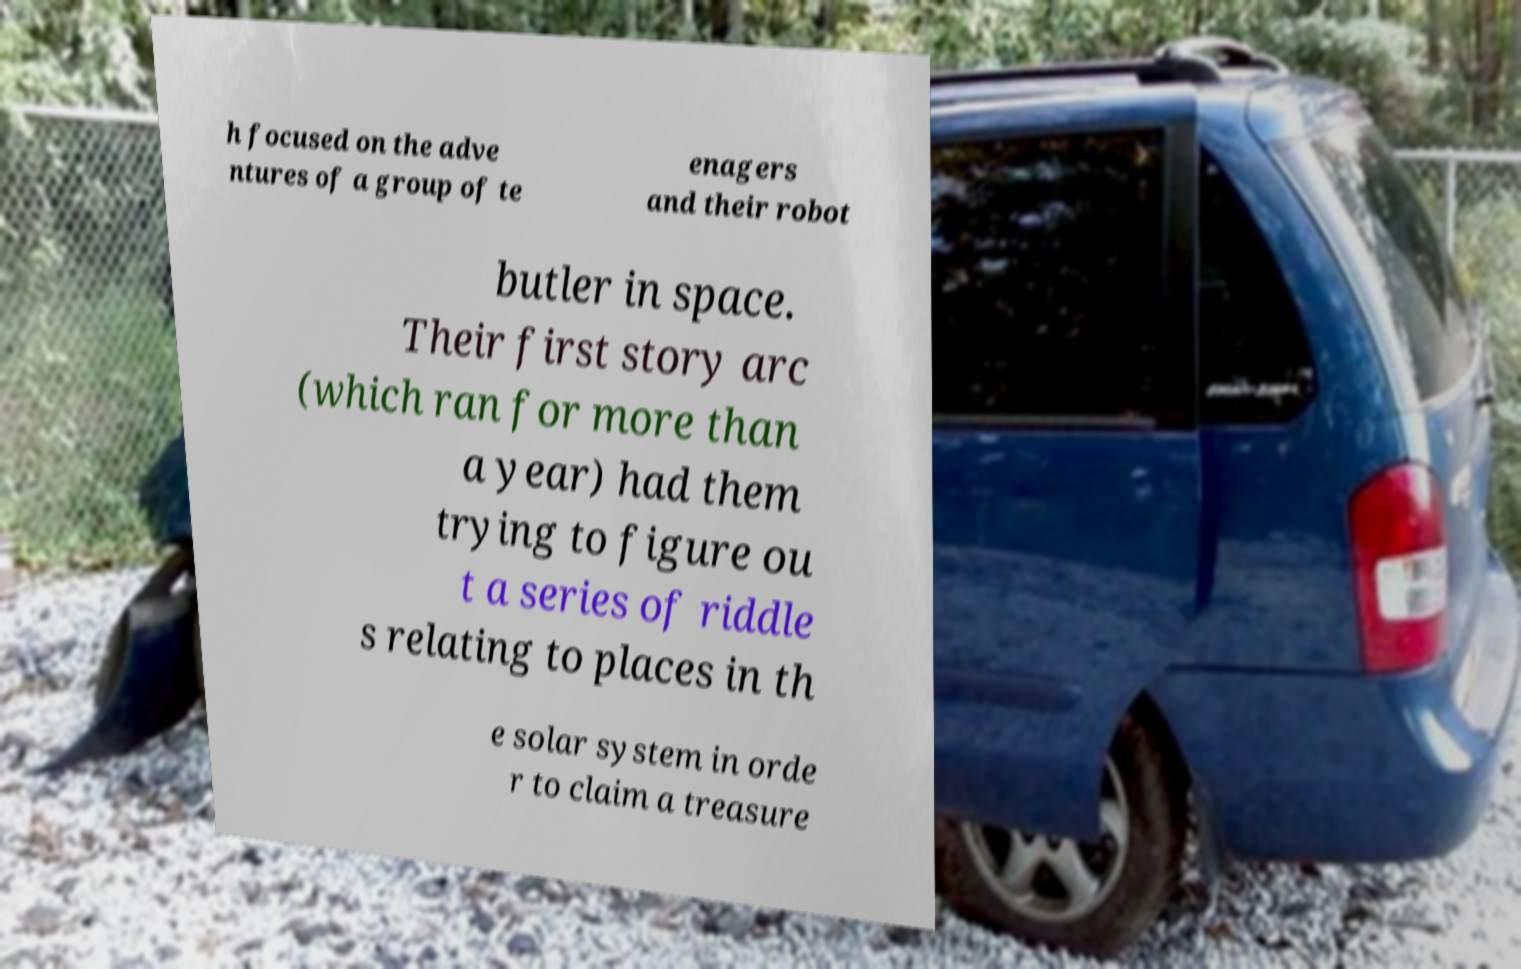For documentation purposes, I need the text within this image transcribed. Could you provide that? h focused on the adve ntures of a group of te enagers and their robot butler in space. Their first story arc (which ran for more than a year) had them trying to figure ou t a series of riddle s relating to places in th e solar system in orde r to claim a treasure 